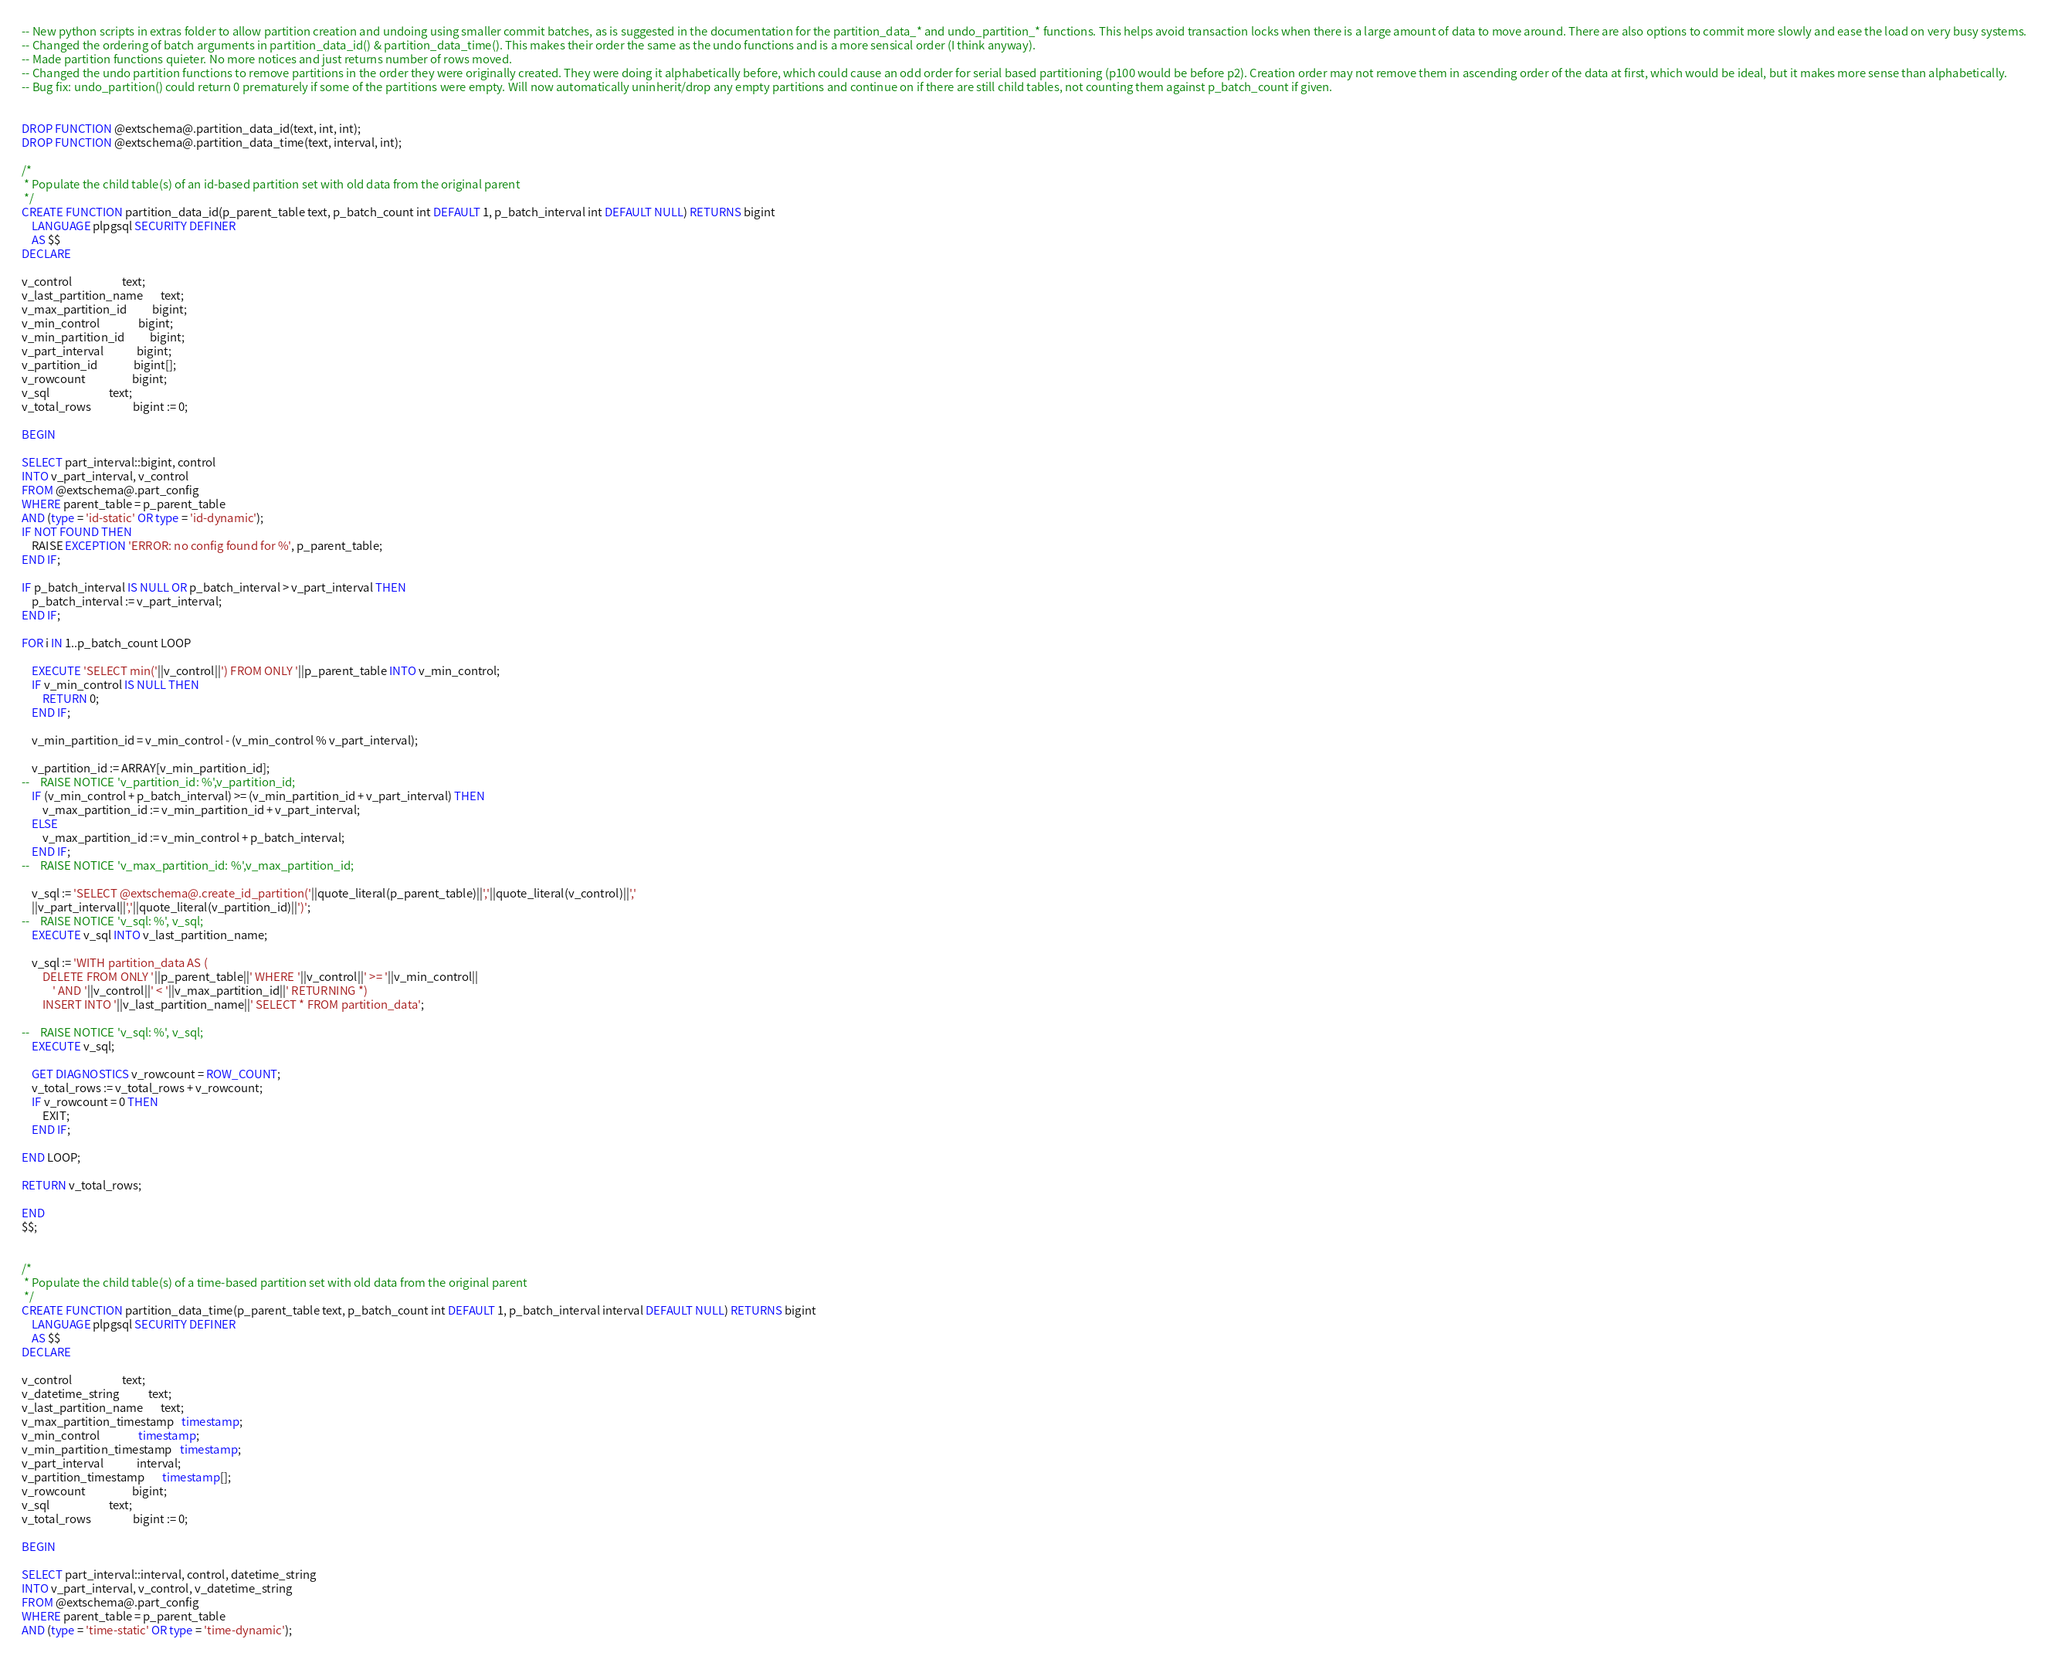<code> <loc_0><loc_0><loc_500><loc_500><_SQL_>-- New python scripts in extras folder to allow partition creation and undoing using smaller commit batches, as is suggested in the documentation for the partition_data_* and undo_partition_* functions. This helps avoid transaction locks when there is a large amount of data to move around. There are also options to commit more slowly and ease the load on very busy systems.
-- Changed the ordering of batch arguments in partition_data_id() & partition_data_time(). This makes their order the same as the undo functions and is a more sensical order (I think anyway).
-- Made partition functions quieter. No more notices and just returns number of rows moved.
-- Changed the undo partition functions to remove partitions in the order they were originally created. They were doing it alphabetically before, which could cause an odd order for serial based partitioning (p100 would be before p2). Creation order may not remove them in ascending order of the data at first, which would be ideal, but it makes more sense than alphabetically.
-- Bug fix: undo_partition() could return 0 prematurely if some of the partitions were empty. Will now automatically uninherit/drop any empty partitions and continue on if there are still child tables, not counting them against p_batch_count if given.


DROP FUNCTION @extschema@.partition_data_id(text, int, int);
DROP FUNCTION @extschema@.partition_data_time(text, interval, int);

/*
 * Populate the child table(s) of an id-based partition set with old data from the original parent
 */
CREATE FUNCTION partition_data_id(p_parent_table text, p_batch_count int DEFAULT 1, p_batch_interval int DEFAULT NULL) RETURNS bigint
    LANGUAGE plpgsql SECURITY DEFINER
    AS $$
DECLARE

v_control                   text;
v_last_partition_name       text;
v_max_partition_id          bigint;
v_min_control               bigint;
v_min_partition_id          bigint;
v_part_interval             bigint;
v_partition_id              bigint[];
v_rowcount                  bigint;
v_sql                       text;
v_total_rows                bigint := 0;

BEGIN

SELECT part_interval::bigint, control
INTO v_part_interval, v_control
FROM @extschema@.part_config 
WHERE parent_table = p_parent_table
AND (type = 'id-static' OR type = 'id-dynamic');
IF NOT FOUND THEN
    RAISE EXCEPTION 'ERROR: no config found for %', p_parent_table;
END IF;

IF p_batch_interval IS NULL OR p_batch_interval > v_part_interval THEN
    p_batch_interval := v_part_interval;
END IF;

FOR i IN 1..p_batch_count LOOP

    EXECUTE 'SELECT min('||v_control||') FROM ONLY '||p_parent_table INTO v_min_control;
    IF v_min_control IS NULL THEN
        RETURN 0;
    END IF;

    v_min_partition_id = v_min_control - (v_min_control % v_part_interval);

    v_partition_id := ARRAY[v_min_partition_id];
--    RAISE NOTICE 'v_partition_id: %',v_partition_id;
    IF (v_min_control + p_batch_interval) >= (v_min_partition_id + v_part_interval) THEN
        v_max_partition_id := v_min_partition_id + v_part_interval;
    ELSE
        v_max_partition_id := v_min_control + p_batch_interval;
    END IF;
--    RAISE NOTICE 'v_max_partition_id: %',v_max_partition_id;

    v_sql := 'SELECT @extschema@.create_id_partition('||quote_literal(p_parent_table)||','||quote_literal(v_control)||','
    ||v_part_interval||','||quote_literal(v_partition_id)||')';
--    RAISE NOTICE 'v_sql: %', v_sql;
    EXECUTE v_sql INTO v_last_partition_name;

    v_sql := 'WITH partition_data AS (
        DELETE FROM ONLY '||p_parent_table||' WHERE '||v_control||' >= '||v_min_control||
            ' AND '||v_control||' < '||v_max_partition_id||' RETURNING *)
        INSERT INTO '||v_last_partition_name||' SELECT * FROM partition_data';        

--    RAISE NOTICE 'v_sql: %', v_sql;
    EXECUTE v_sql;

    GET DIAGNOSTICS v_rowcount = ROW_COUNT;
    v_total_rows := v_total_rows + v_rowcount;
    IF v_rowcount = 0 THEN
        EXIT;
    END IF;

END LOOP; 

RETURN v_total_rows;

END
$$;


/*
 * Populate the child table(s) of a time-based partition set with old data from the original parent
 */
CREATE FUNCTION partition_data_time(p_parent_table text, p_batch_count int DEFAULT 1, p_batch_interval interval DEFAULT NULL) RETURNS bigint
    LANGUAGE plpgsql SECURITY DEFINER
    AS $$
DECLARE

v_control                   text;
v_datetime_string           text;
v_last_partition_name       text;
v_max_partition_timestamp   timestamp;
v_min_control               timestamp;
v_min_partition_timestamp   timestamp;
v_part_interval             interval;
v_partition_timestamp       timestamp[];
v_rowcount                  bigint;
v_sql                       text;
v_total_rows                bigint := 0;

BEGIN

SELECT part_interval::interval, control, datetime_string
INTO v_part_interval, v_control, v_datetime_string
FROM @extschema@.part_config 
WHERE parent_table = p_parent_table
AND (type = 'time-static' OR type = 'time-dynamic');</code> 